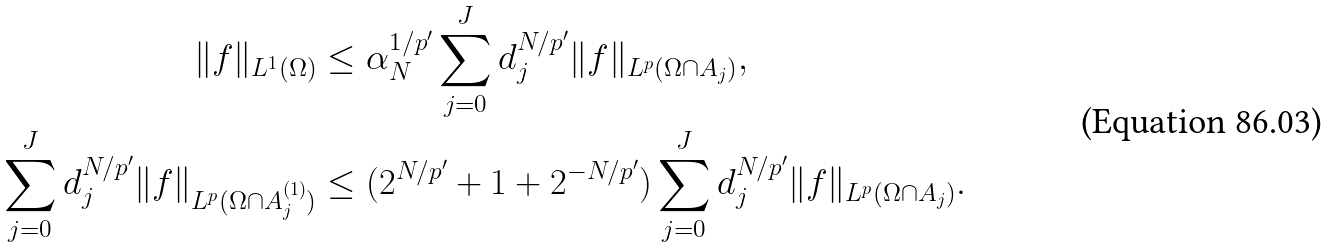Convert formula to latex. <formula><loc_0><loc_0><loc_500><loc_500>\| f \| _ { L ^ { 1 } ( \Omega ) } & \leq \alpha _ { N } ^ { 1 / p ^ { \prime } } \sum _ { j = 0 } ^ { J } d _ { j } ^ { N / p ^ { \prime } } \| f \| _ { L ^ { p } ( \Omega \cap A _ { j } ) } , \\ \sum _ { j = 0 } ^ { J } d _ { j } ^ { N / p ^ { \prime } } \| f \| _ { L ^ { p } ( \Omega \cap A _ { j } ^ { ( 1 ) } ) } & \leq ( 2 ^ { N / p ^ { \prime } } + 1 + 2 ^ { - N / p ^ { \prime } } ) \sum _ { j = 0 } ^ { J } d _ { j } ^ { N / p ^ { \prime } } \| f \| _ { L ^ { p } ( \Omega \cap A _ { j } ) } .</formula> 